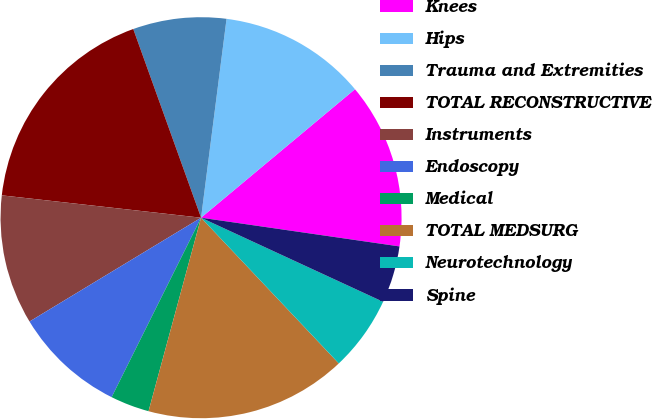Convert chart. <chart><loc_0><loc_0><loc_500><loc_500><pie_chart><fcel>Knees<fcel>Hips<fcel>Trauma and Extremities<fcel>TOTAL RECONSTRUCTIVE<fcel>Instruments<fcel>Endoscopy<fcel>Medical<fcel>TOTAL MEDSURG<fcel>Neurotechnology<fcel>Spine<nl><fcel>13.36%<fcel>11.9%<fcel>7.52%<fcel>17.73%<fcel>10.44%<fcel>8.98%<fcel>3.14%<fcel>16.27%<fcel>6.06%<fcel>4.6%<nl></chart> 